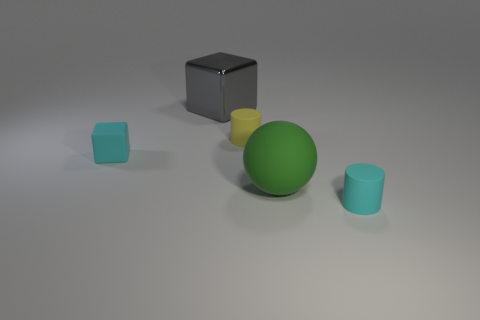Is there anything else that is the same shape as the big green rubber object?
Your answer should be very brief. No. Is the color of the metal thing the same as the matte cylinder behind the ball?
Your response must be concise. No. Is there anything else that is the same size as the yellow object?
Give a very brief answer. Yes. What is the size of the object that is both behind the green matte sphere and in front of the small yellow matte cylinder?
Your answer should be very brief. Small. What is the shape of the large green object that is the same material as the yellow cylinder?
Your answer should be compact. Sphere. Are the green thing and the small cyan thing that is right of the big gray metallic cube made of the same material?
Provide a succinct answer. Yes. There is a tiny cyan matte thing right of the matte cube; is there a green rubber sphere that is to the right of it?
Your response must be concise. No. There is another thing that is the same shape as the big shiny object; what material is it?
Offer a terse response. Rubber. There is a cube to the left of the gray metal block; what number of things are on the left side of it?
Ensure brevity in your answer.  0. Is there anything else that is the same color as the tiny rubber block?
Keep it short and to the point. Yes. 